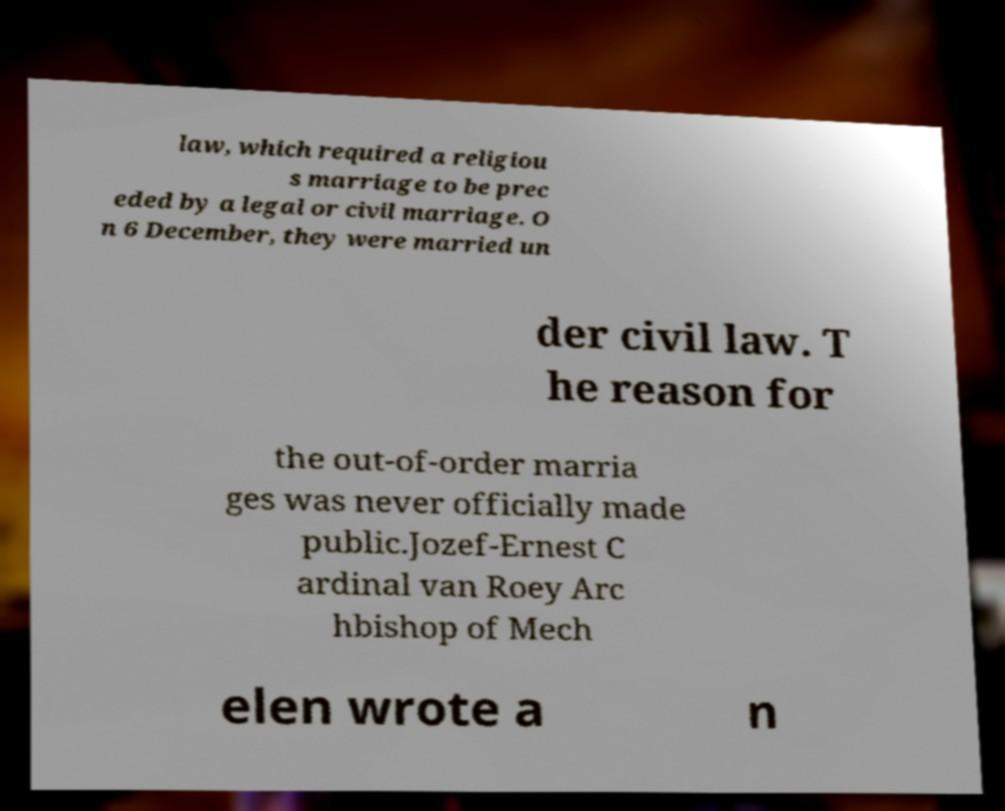What messages or text are displayed in this image? I need them in a readable, typed format. law, which required a religiou s marriage to be prec eded by a legal or civil marriage. O n 6 December, they were married un der civil law. T he reason for the out-of-order marria ges was never officially made public.Jozef-Ernest C ardinal van Roey Arc hbishop of Mech elen wrote a n 